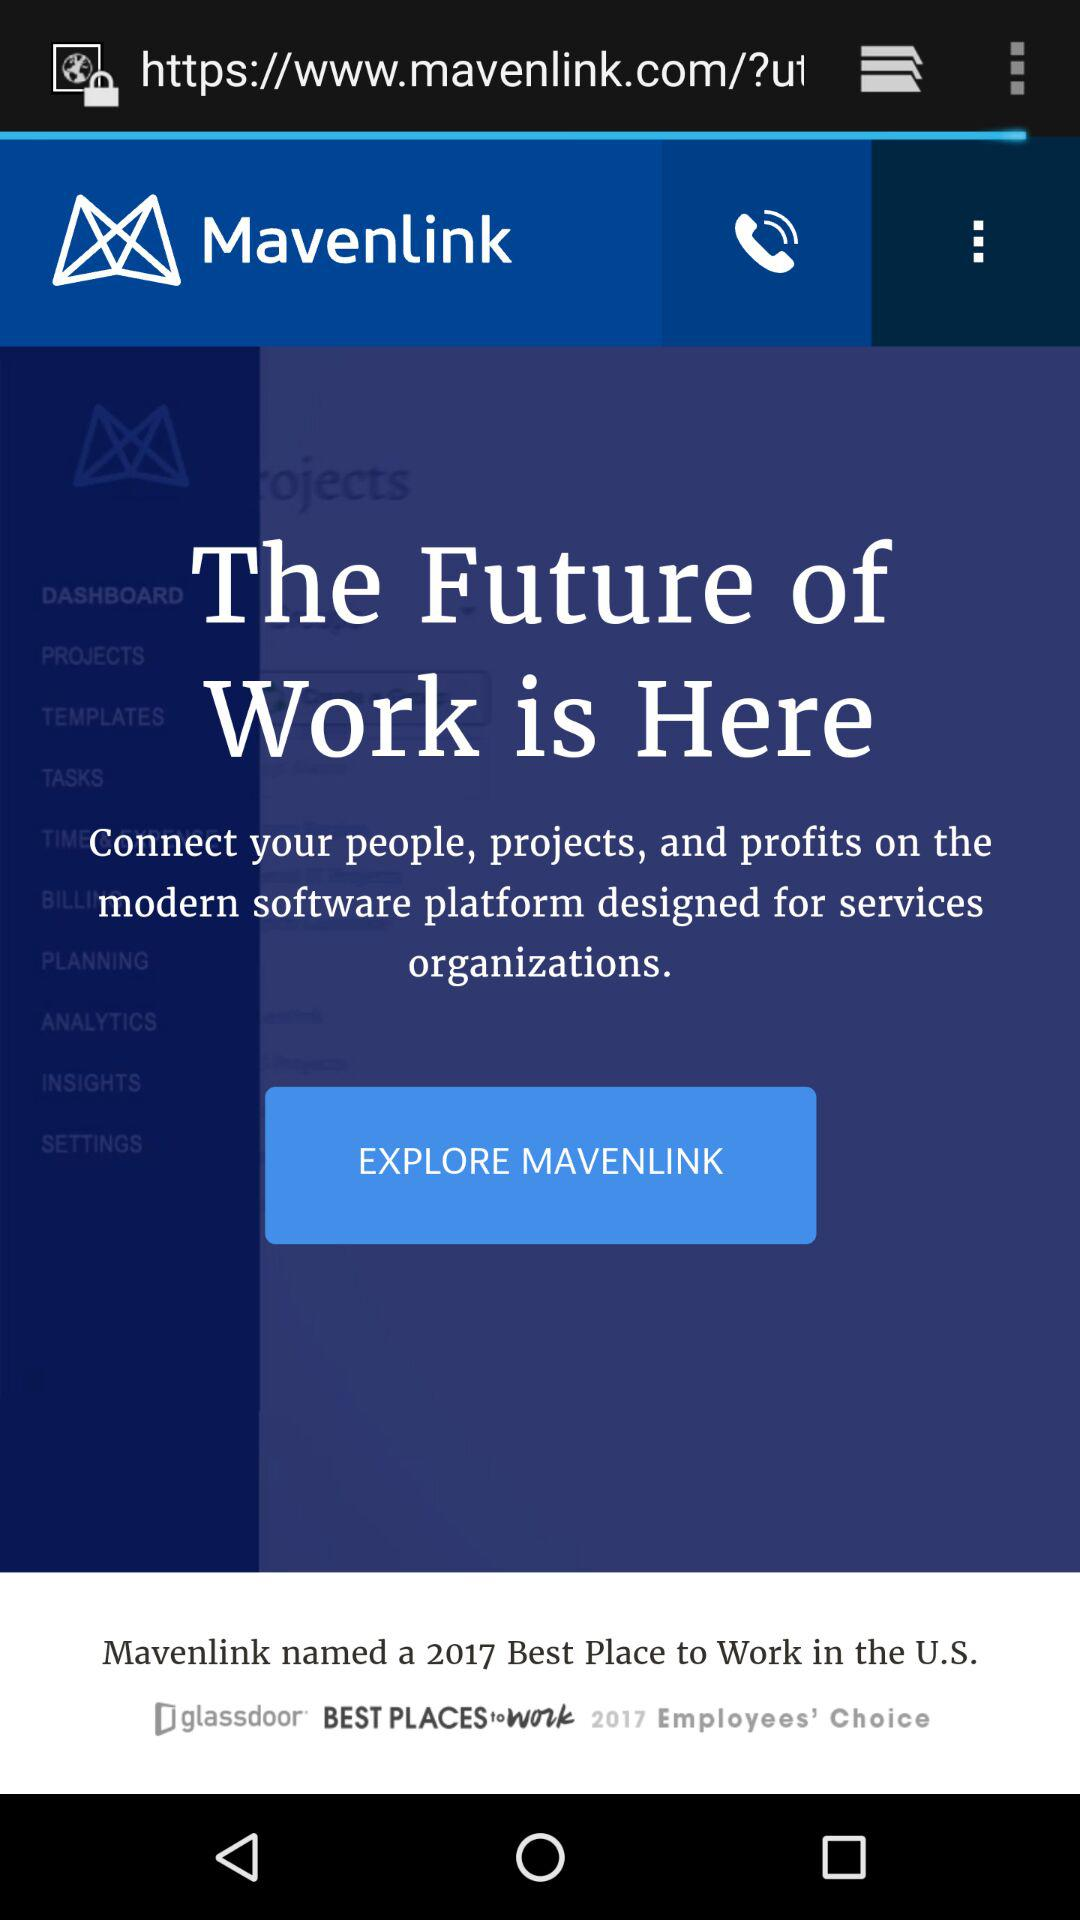What is the name of the company? The name of the company is "Mavenlink". 